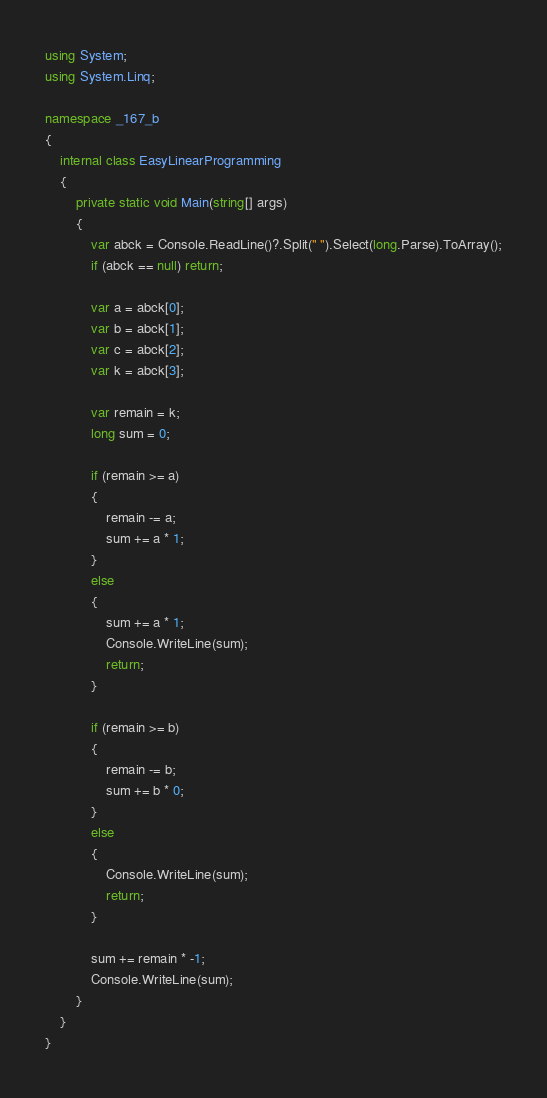<code> <loc_0><loc_0><loc_500><loc_500><_C#_>using System;
using System.Linq;

namespace _167_b
{
    internal class EasyLinearProgramming
    {
        private static void Main(string[] args)
        {
            var abck = Console.ReadLine()?.Split(" ").Select(long.Parse).ToArray();
            if (abck == null) return;

            var a = abck[0];
            var b = abck[1];
            var c = abck[2];
            var k = abck[3];

            var remain = k;
            long sum = 0;

            if (remain >= a)
            {
                remain -= a;
                sum += a * 1;
            }
            else
            {
                sum += a * 1;
                Console.WriteLine(sum);
                return;
            }

            if (remain >= b)
            {
                remain -= b;
                sum += b * 0;
            }
            else
            {
                Console.WriteLine(sum);
                return;
            }

            sum += remain * -1;
            Console.WriteLine(sum);
        }
    }
}</code> 